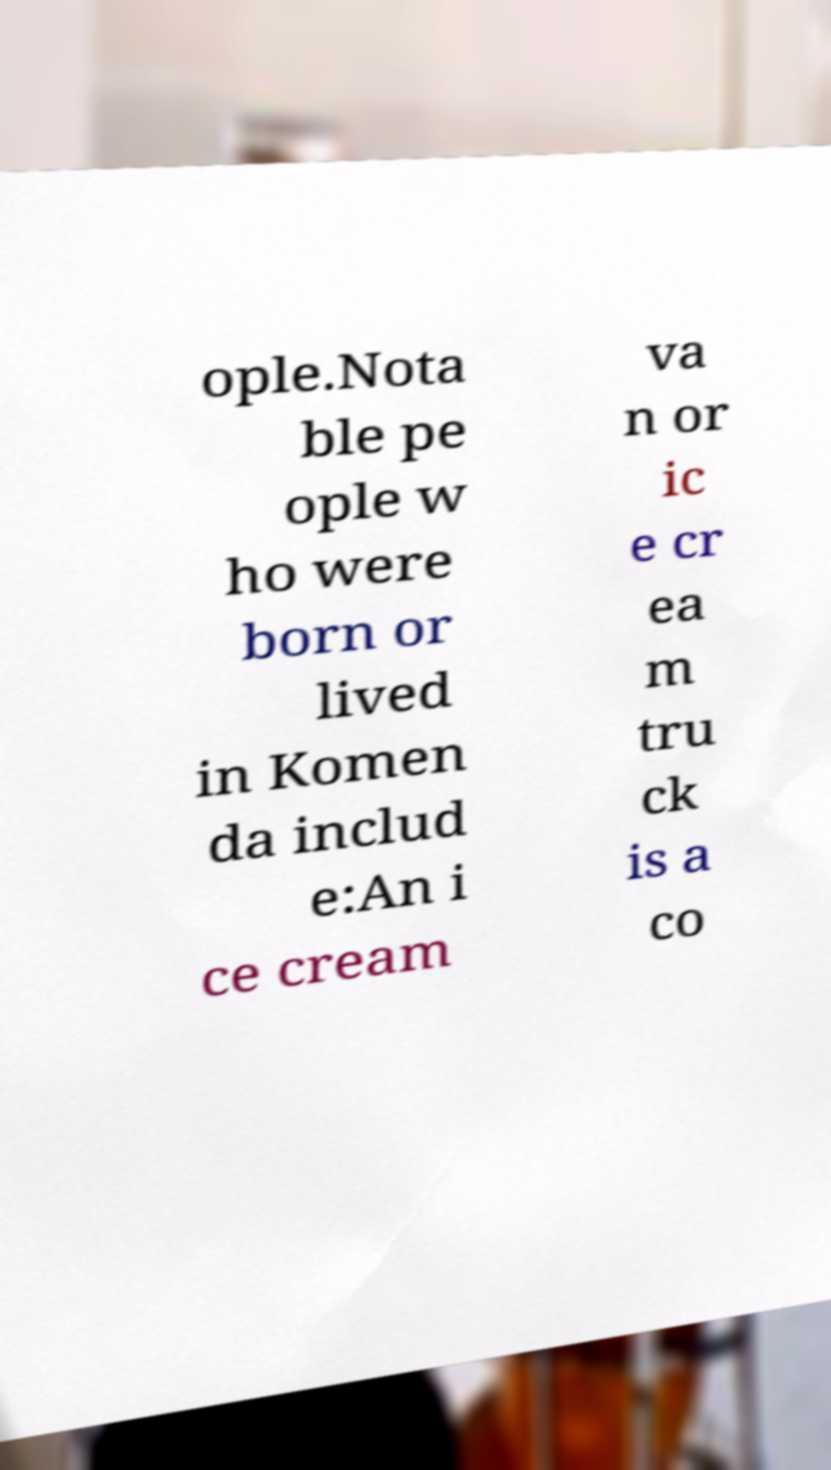What messages or text are displayed in this image? I need them in a readable, typed format. ople.Nota ble pe ople w ho were born or lived in Komen da includ e:An i ce cream va n or ic e cr ea m tru ck is a co 